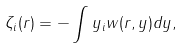Convert formula to latex. <formula><loc_0><loc_0><loc_500><loc_500>\zeta _ { i } ( { r } ) = - \int y _ { i } w ( { r } , { y } ) d { y } ,</formula> 